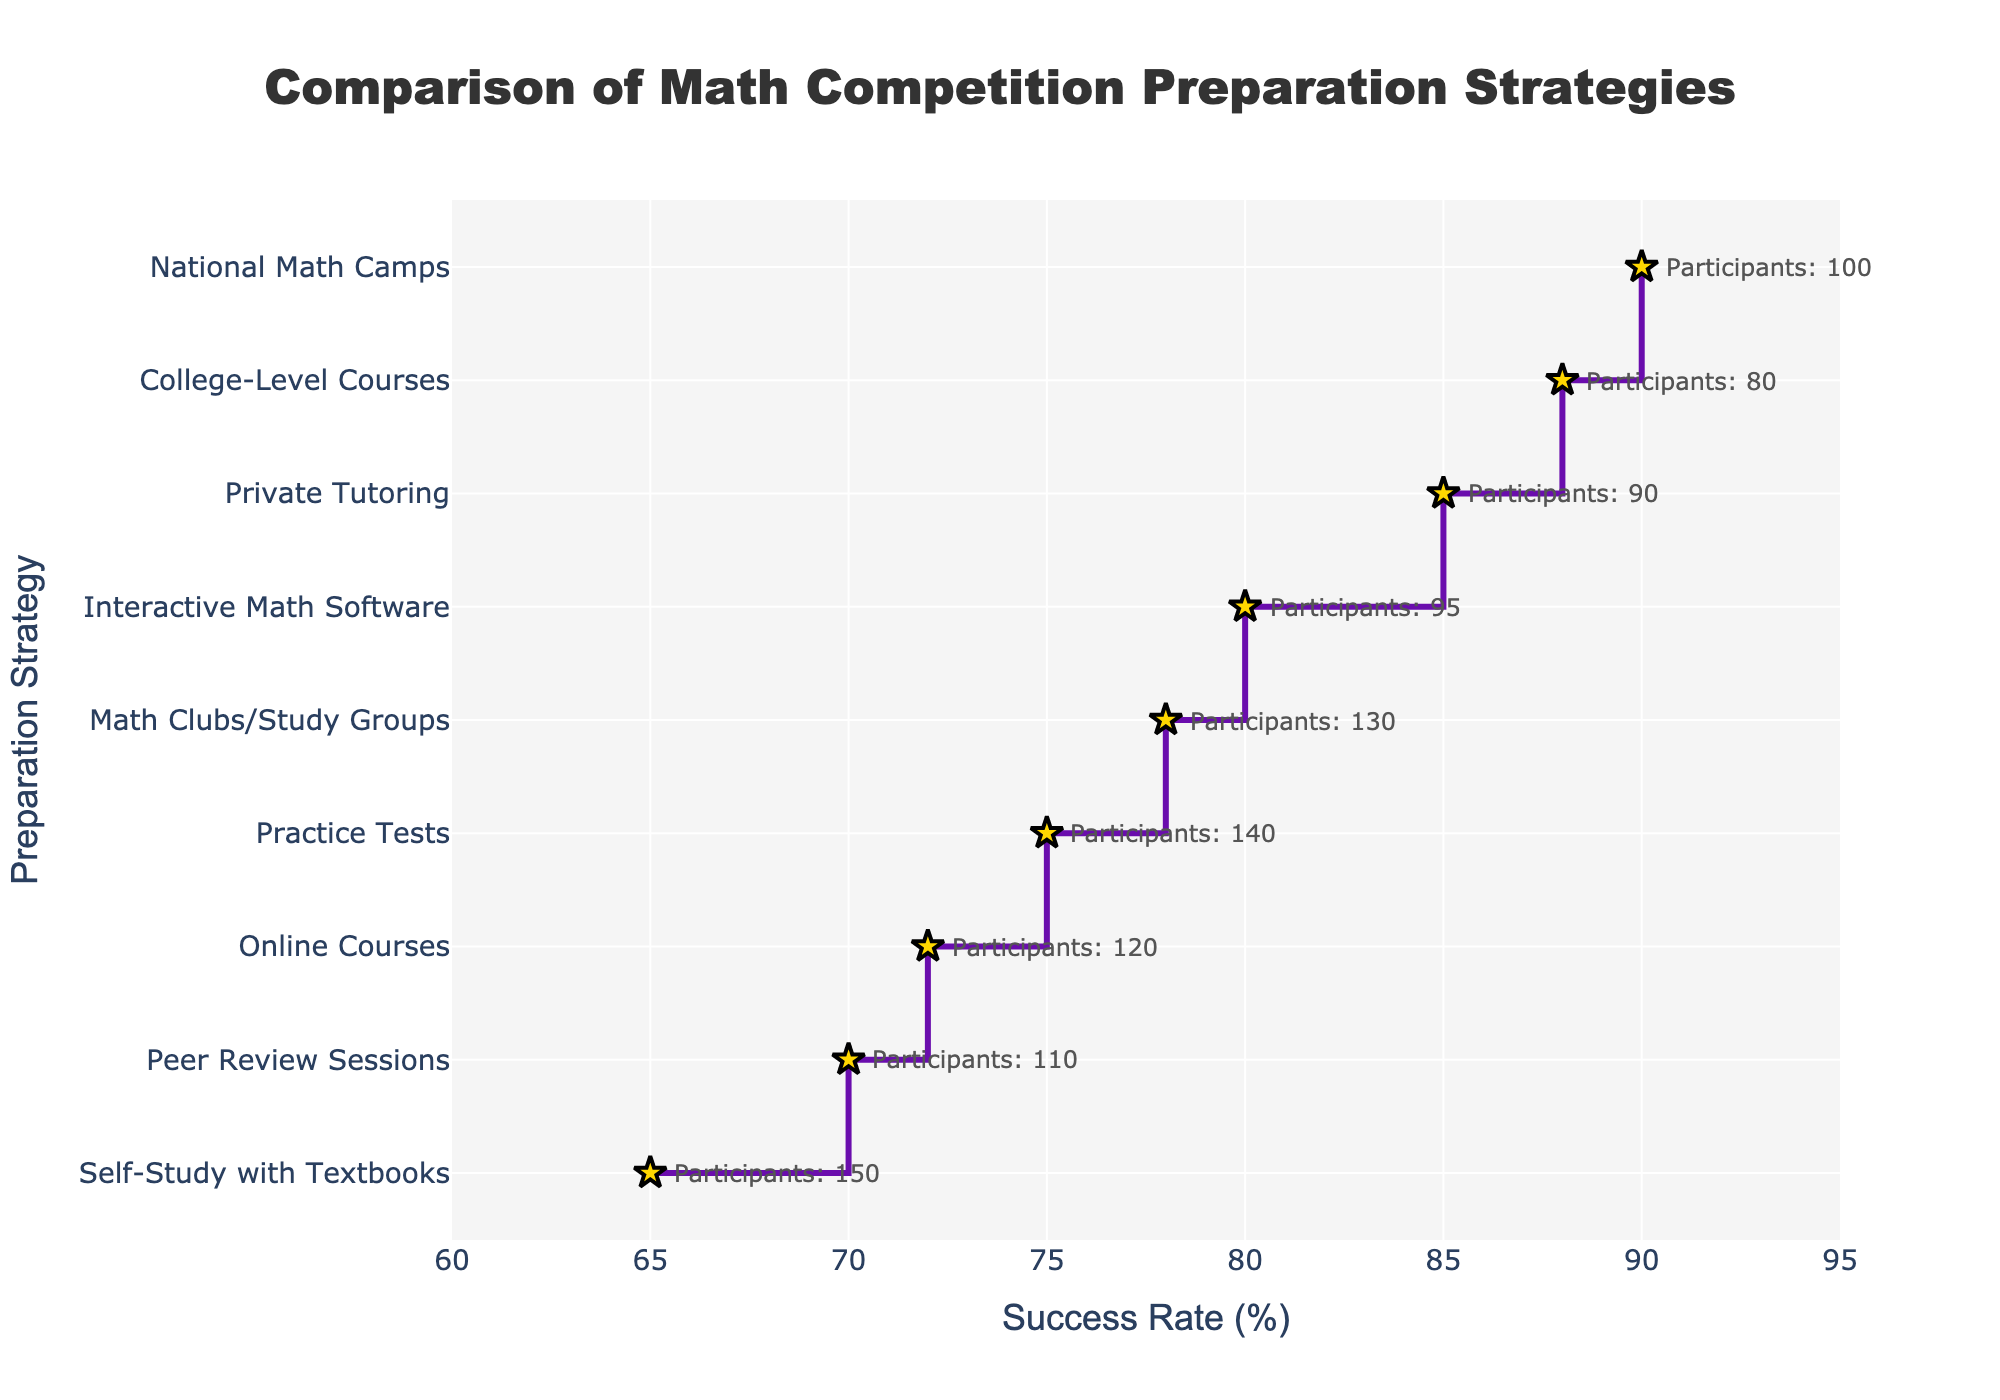How many preparation strategies are compared in this plot? To find the number of preparation strategies compared, we can count the number of data points (markers) in the plot. By examining the plot, we see there are 9 different markers along the y-axis.
Answer: 9 Which preparation strategy has the highest success rate? To identify the highest success rate, look at the topmost point on the vertical axis. The corresponding point on the horizontal axis represents the highest success rate, which is associated with "National Math Camps" at 90%.
Answer: National Math Camps What is the difference in success rate between the strategy with the highest success rate and the lowest success rate? Subtract the success rate of the strategy with the lowest success rate from that with the highest success rate. The "Self-Study with Textbooks" has a success rate of 65%, and "National Math Camps" has a success rate of 90%. So, 90% - 65% = 25%.
Answer: 25% Which strategy has more participants: "Online Courses" or "Private Tutoring"? Compare the number of participants provided for "Online Courses" and "Private Tutoring". "Online Courses" has 120 participants, while "Private Tutoring" has 90 participants.
Answer: Online Courses What is the average success rate of all preparation strategies? To find the average success rate, add all the success rates together and divide by the number of strategies. Sum: 65+72+85+78+90+88+70+75+80 = 703. Number of strategies: 9. Average: 703 / 9 ≈ 78.11%.
Answer: 78.11% What is the success rate of the strategy with the second highest number of participants? First, identify the strategy with the second highest number of participants by ranking them. "Self-Study with Textbooks" has the most participants (150), and "Practice Tests" has the second most (140). The success rate for "Practice Tests" is 75%.
Answer: 75% Between "Peer Review Sessions" and "Math Clubs/Study Groups", which has a higher success rate and by how much? Look at the success rates for "Peer Review Sessions" (70%) and "Math Clubs/Study Groups" (78%). The difference in success rates is 78% - 70% = 8%.
Answer: Math Clubs/Study Groups by 8% Which strategy shows a success rate closest to the median of all the success rates? To find the median success rate, sort the success rates and find the middle value. Sorted: 65, 70, 72, 75, 78, 80, 85, 88, 90. The median is the middle value: 78. The strategy with a success rate of 78% is "Math Clubs/Study Groups".
Answer: Math Clubs/Study Groups Are there any strategies where the number of participants is less than 100, and if so, what is the success rate of the strategy with the highest success rate among them? Identify strategies with fewer than 100 participants: "Private Tutoring" (90), "National Math Camps" (100, excluded), "College-Level Courses" (80), "Interactive Math Software" (95). The highest success rate among these strategies is "College-Level Courses" at 88%.
Answer: 88% 